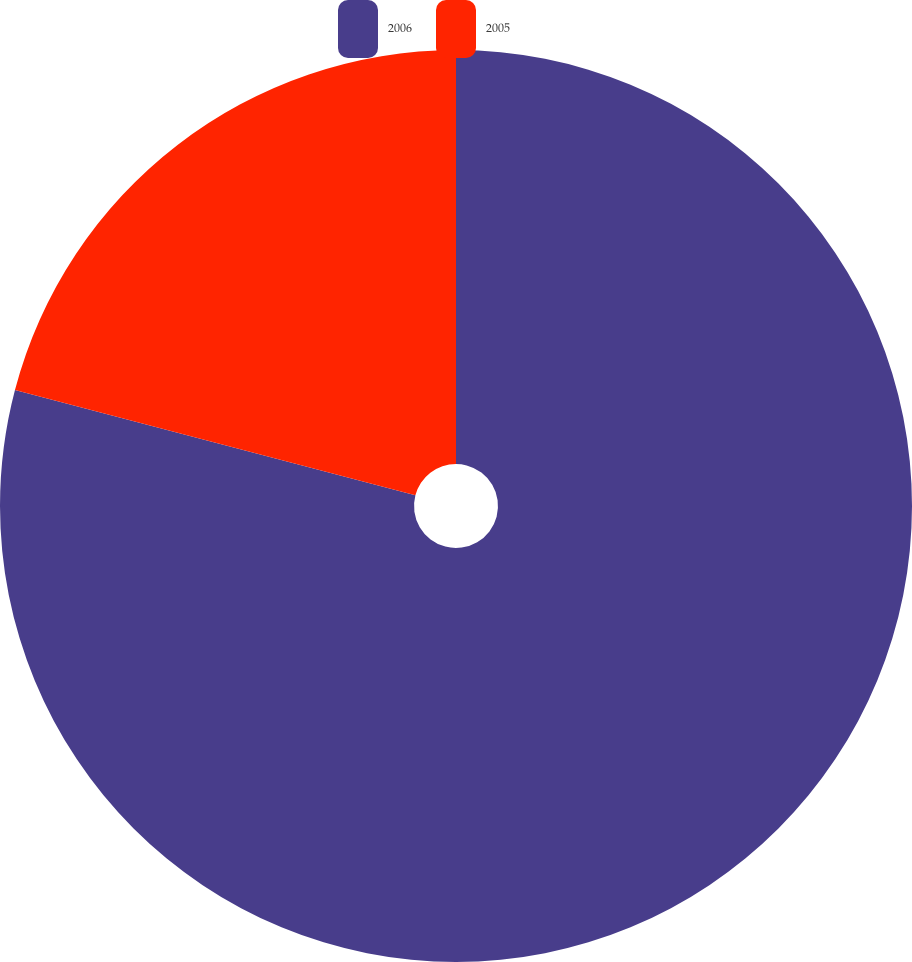Convert chart. <chart><loc_0><loc_0><loc_500><loc_500><pie_chart><fcel>2006<fcel>2005<nl><fcel>79.09%<fcel>20.91%<nl></chart> 